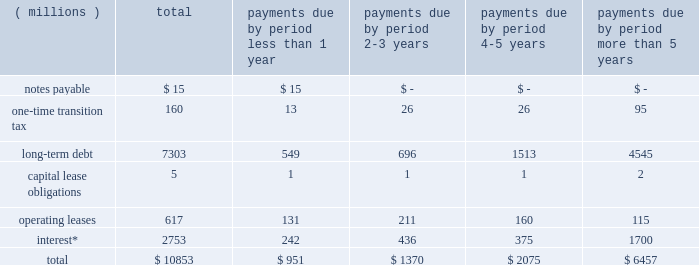Liquidity and capital resources we currently expect to fund all of our cash requirements which are reasonably foreseeable for 2018 , including scheduled debt repayments , new investments in the business , share repurchases , dividend payments , possible business acquisitions and pension contributions , with cash from operating activities , and as needed , additional short-term and/or long-term borrowings .
We continue to expect our operating cash flow to remain strong .
As of december 31 , 2017 , we had $ 211 million of cash and cash equivalents on hand , of which $ 151 million was held outside of the as of december 31 , 2016 , we had $ 327 million of cash and cash equivalents on hand , of which $ 184 million was held outside of the u.s .
As of december 31 , 2015 , we had $ 26 million of deferred tax liabilities for pre-acquisition foreign earnings associated with the legacy nalco entities and legacy champion entities that we intended to repatriate .
These liabilities were recorded as part of the respective purchase price accounting of each transaction .
The remaining foreign earnings were repatriated in 2016 , reducing the deferred tax liabilities to zero at december 31 , 2016 .
As of december 31 , 2017 we had a $ 2.0 billion multi-year credit facility , which expires in november 2022 .
The credit facility has been established with a diverse syndicate of banks .
There were no borrowings under our credit facility as of december 31 , 2017 or 2016 .
The credit facility supports our $ 2.0 billion u.s .
Commercial paper program and $ 2.0 billion european commercial paper program .
Combined borrowing under these two commercial paper programs may not exceed $ 2.0 billion .
At year-end , we had no amount outstanding under the european commercial paper program and no amount outstanding under the u.s .
Commercial paper program .
Additionally , we have uncommitted credit lines of $ 660 million with major international banks and financial institutions to support our general global funding needs .
Most of these lines are used to support global cash pooling structures .
Approximately $ 643 million of these credit lines were available for use as of year-end 2017 .
Bank supported letters of credit , surety bonds and guarantees total $ 198 million and represent commercial business transactions .
We do not have any other significant unconditional purchase obligations or commercial commitments .
As of december 31 , 2017 , our short-term borrowing program was rated a-2 by standard & poor 2019s and p-2 by moody 2019s .
As of december 31 , 2017 , standard & poor 2019s and moody 2019s rated our long-term credit at a- ( stable outlook ) and baa1 ( stable outlook ) , respectively .
A reduction in our credit ratings could limit or preclude our ability to issue commercial paper under our current programs , or could also adversely affect our ability to renew existing , or negotiate new , credit facilities in the future and could increase the cost of these facilities .
Should this occur , we could seek additional sources of funding , including issuing additional term notes or bonds .
In addition , we have the ability , at our option , to draw upon our $ 2.0 billion of committed credit facility .
We are in compliance with our debt covenants and other requirements of our credit agreements and indentures .
A schedule of our various obligations as of december 31 , 2017 are summarized in the table: .
* interest on variable rate debt was calculated using the interest rate at year-end 2017 .
During the fourth quarter of 2017 , we recorded a one-time transition tax related to enactment of the tax act .
The expense is primarily related to the one-time transition tax , which is payable over eight years .
As discussed further in note 12 , this balance is a provisional amount and is subject to adjustment during the measurement period of up to one year following the enactment of the tax act , as provided by recent sec guidance .
As of december 31 , 2017 , our gross liability for uncertain tax positions was $ 68 million .
We are not able to reasonably estimate the amount by which the liability will increase or decrease over an extended period of time or whether a cash settlement of the liability will be required .
Therefore , these amounts have been excluded from the schedule of contractual obligations. .
What portion of the balance of cash and cash equivalents on hand is held outside u.s . in 2017? 
Computations: (151 / 211)
Answer: 0.71564. 